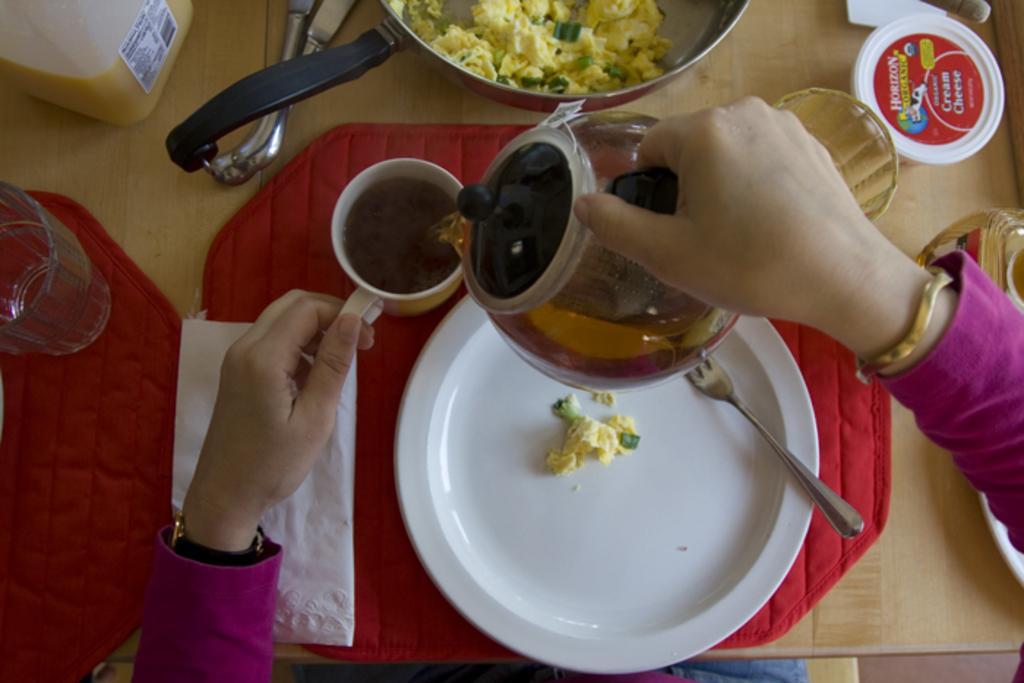Can you describe this image briefly? In the picture I can see a person is holding a cup and a kettle in hands. I can also see food item and a spoon in a plate. I can also see glasses, food item in a pan, red color clothes and some other objects on a wooden surface. 